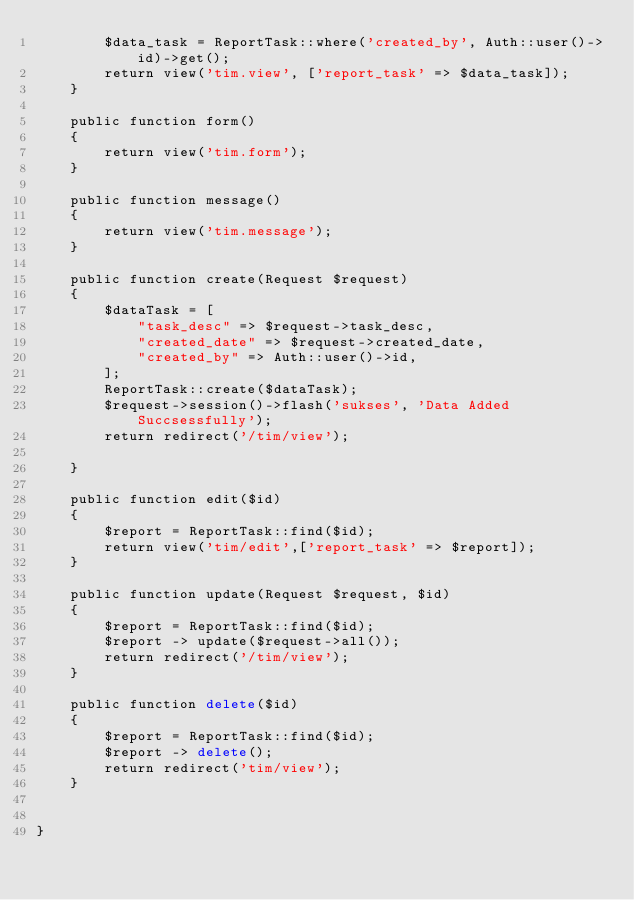Convert code to text. <code><loc_0><loc_0><loc_500><loc_500><_PHP_>        $data_task = ReportTask::where('created_by', Auth::user()->id)->get();
        return view('tim.view', ['report_task' => $data_task]);
    }

    public function form()
    {
        return view('tim.form');
    }

    public function message()
    {
        return view('tim.message');
    }

    public function create(Request $request)
    {
        $dataTask = [
            "task_desc" => $request->task_desc,
            "created_date" => $request->created_date,
            "created_by" => Auth::user()->id,
        ];
        ReportTask::create($dataTask);
        $request->session()->flash('sukses', 'Data Added Succsessfully');
        return redirect('/tim/view');

    }

    public function edit($id)
    {
        $report = ReportTask::find($id);
        return view('tim/edit',['report_task' => $report]);
    }

    public function update(Request $request, $id)
    {
        $report = ReportTask::find($id);
        $report -> update($request->all());
        return redirect('/tim/view');
    }

    public function delete($id)
    {
        $report = ReportTask::find($id);
        $report -> delete();
        return redirect('tim/view');
    }


}
</code> 